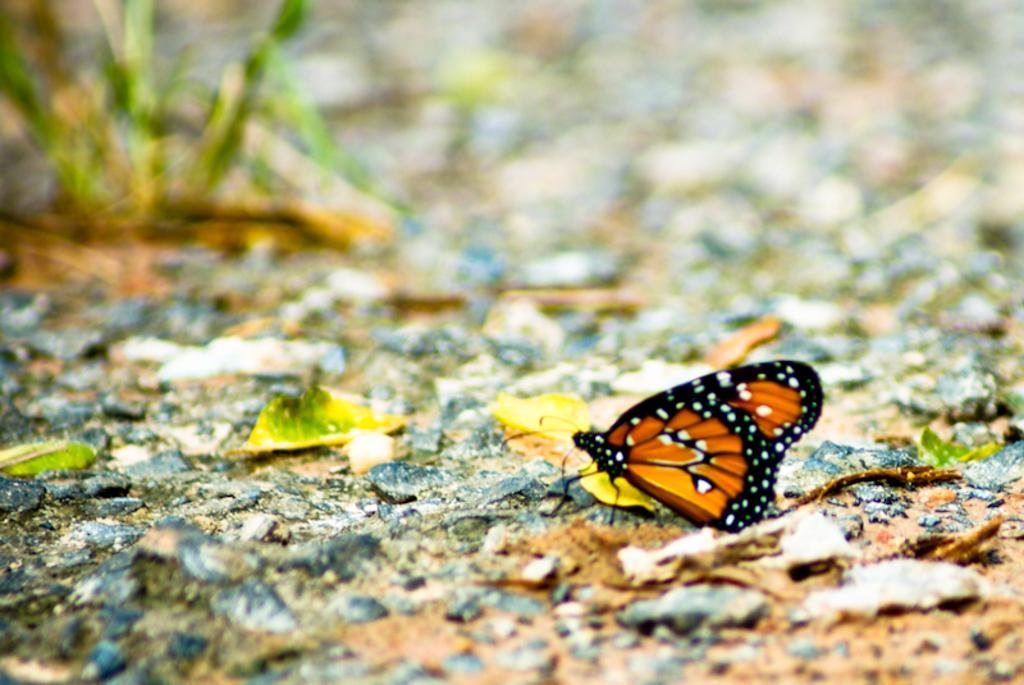In one or two sentences, can you explain what this image depicts? In this picture, we can see a butterfly on the path and there is a blurred background. 